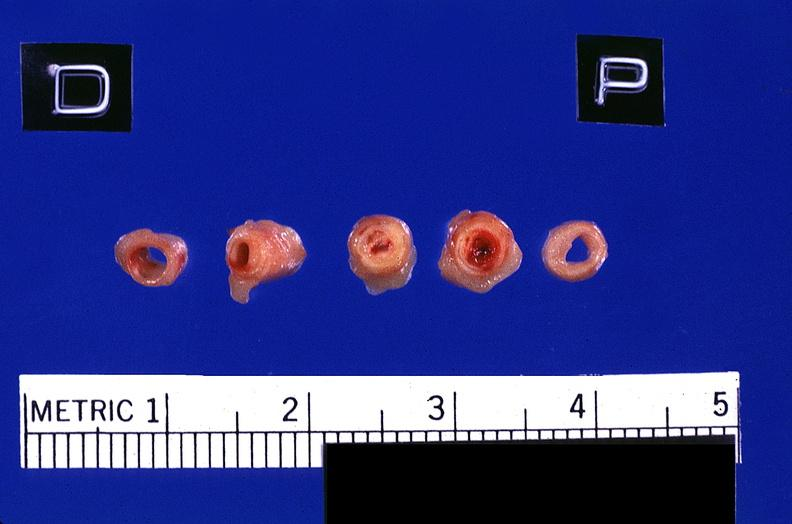what is present?
Answer the question using a single word or phrase. Vasculature 